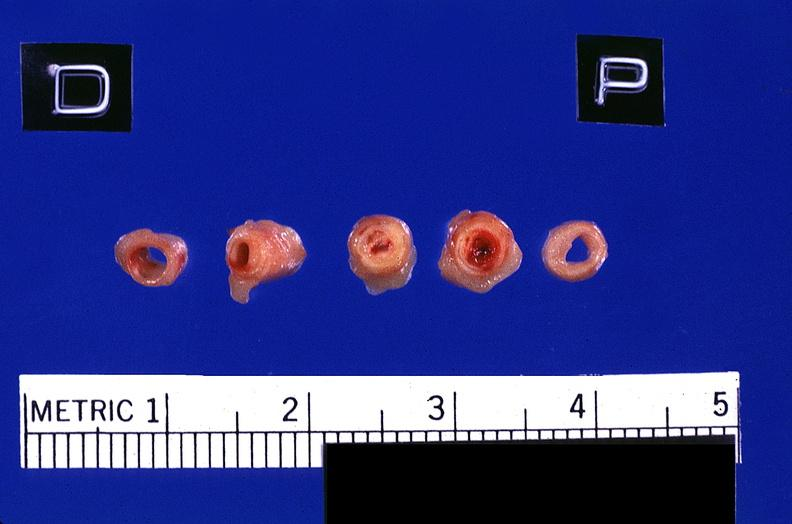what is present?
Answer the question using a single word or phrase. Vasculature 